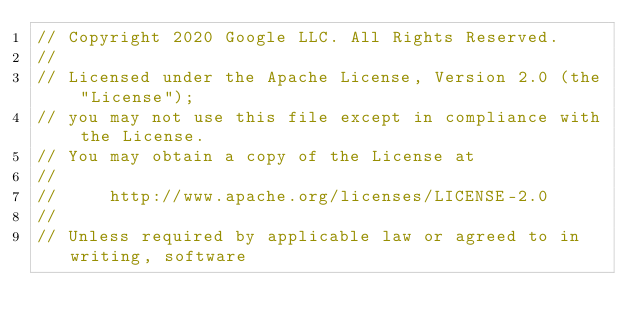Convert code to text. <code><loc_0><loc_0><loc_500><loc_500><_C_>// Copyright 2020 Google LLC. All Rights Reserved.
//
// Licensed under the Apache License, Version 2.0 (the "License");
// you may not use this file except in compliance with the License.
// You may obtain a copy of the License at
//
//     http://www.apache.org/licenses/LICENSE-2.0
//
// Unless required by applicable law or agreed to in writing, software</code> 